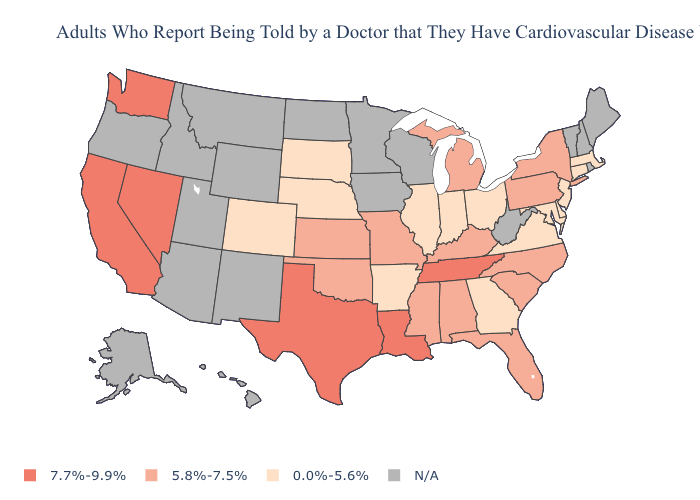What is the lowest value in the Northeast?
Short answer required. 0.0%-5.6%. Name the states that have a value in the range 7.7%-9.9%?
Quick response, please. California, Louisiana, Nevada, Tennessee, Texas, Washington. What is the value of Connecticut?
Give a very brief answer. 0.0%-5.6%. Is the legend a continuous bar?
Short answer required. No. What is the value of Nevada?
Be succinct. 7.7%-9.9%. What is the highest value in the USA?
Keep it brief. 7.7%-9.9%. Is the legend a continuous bar?
Keep it brief. No. Name the states that have a value in the range N/A?
Write a very short answer. Alaska, Arizona, Hawaii, Idaho, Iowa, Maine, Minnesota, Montana, New Hampshire, New Mexico, North Dakota, Oregon, Rhode Island, Utah, Vermont, West Virginia, Wisconsin, Wyoming. Which states have the lowest value in the USA?
Quick response, please. Arkansas, Colorado, Connecticut, Delaware, Georgia, Illinois, Indiana, Maryland, Massachusetts, Nebraska, New Jersey, Ohio, South Dakota, Virginia. Does the first symbol in the legend represent the smallest category?
Write a very short answer. No. Name the states that have a value in the range N/A?
Give a very brief answer. Alaska, Arizona, Hawaii, Idaho, Iowa, Maine, Minnesota, Montana, New Hampshire, New Mexico, North Dakota, Oregon, Rhode Island, Utah, Vermont, West Virginia, Wisconsin, Wyoming. Name the states that have a value in the range N/A?
Write a very short answer. Alaska, Arizona, Hawaii, Idaho, Iowa, Maine, Minnesota, Montana, New Hampshire, New Mexico, North Dakota, Oregon, Rhode Island, Utah, Vermont, West Virginia, Wisconsin, Wyoming. Name the states that have a value in the range 5.8%-7.5%?
Be succinct. Alabama, Florida, Kansas, Kentucky, Michigan, Mississippi, Missouri, New York, North Carolina, Oklahoma, Pennsylvania, South Carolina. Name the states that have a value in the range 5.8%-7.5%?
Short answer required. Alabama, Florida, Kansas, Kentucky, Michigan, Mississippi, Missouri, New York, North Carolina, Oklahoma, Pennsylvania, South Carolina. What is the value of Colorado?
Quick response, please. 0.0%-5.6%. 